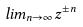Convert formula to latex. <formula><loc_0><loc_0><loc_500><loc_500>l i m _ { n \rightarrow \infty } z ^ { \pm n }</formula> 